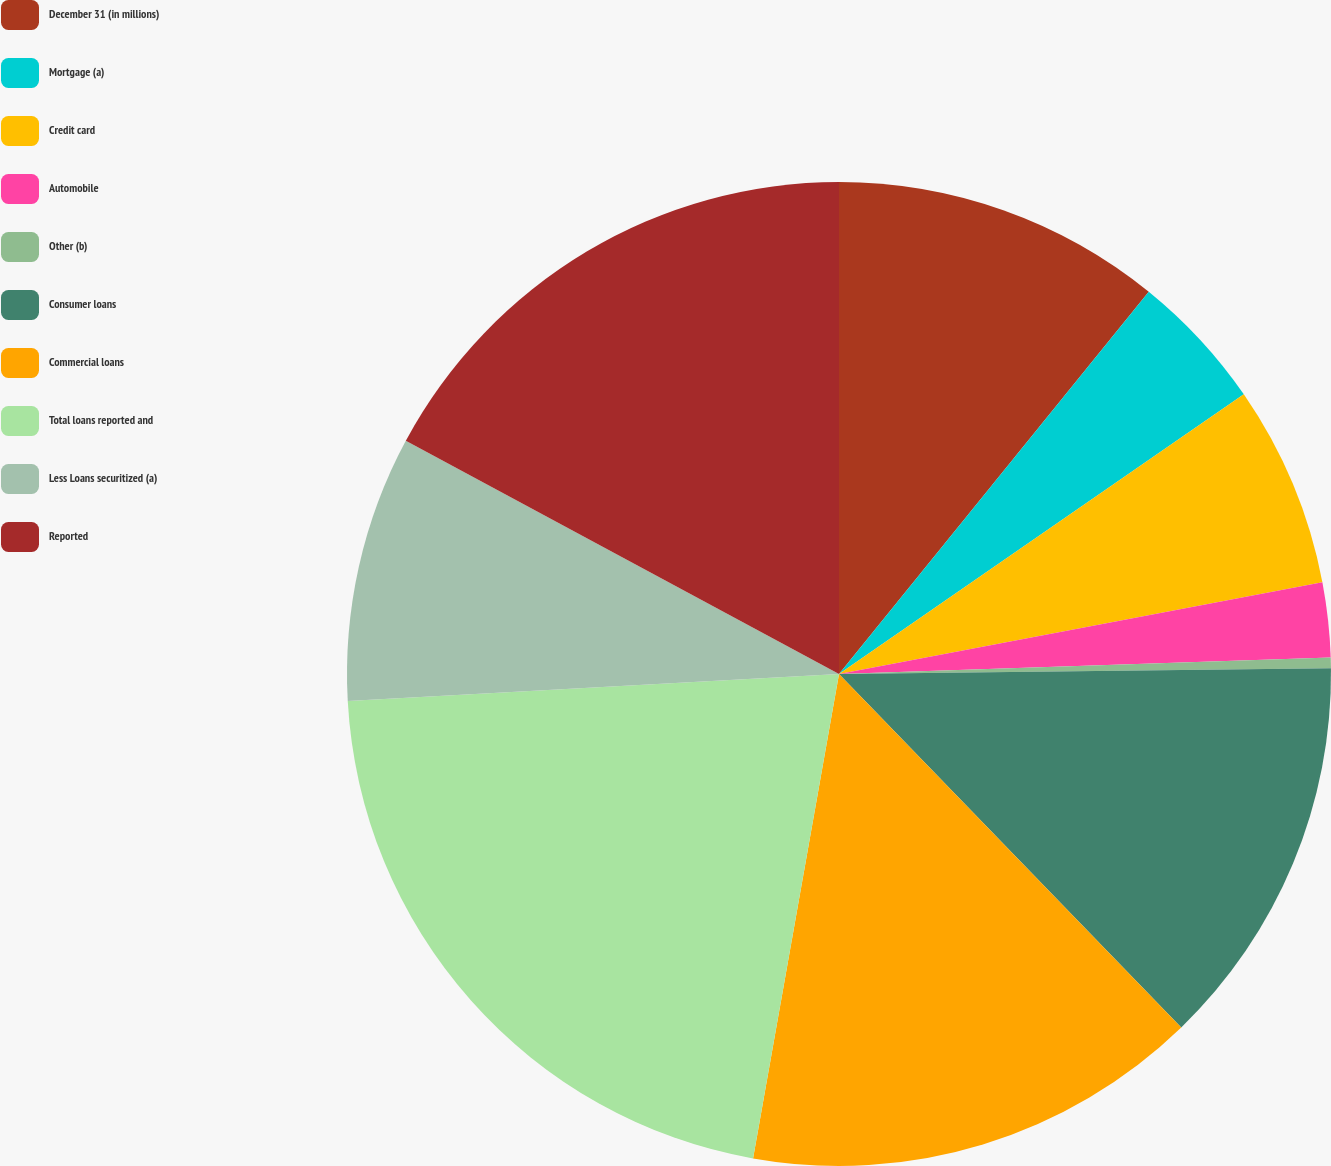<chart> <loc_0><loc_0><loc_500><loc_500><pie_chart><fcel>December 31 (in millions)<fcel>Mortgage (a)<fcel>Credit card<fcel>Automobile<fcel>Other (b)<fcel>Consumer loans<fcel>Commercial loans<fcel>Total loans reported and<fcel>Less Loans securitized (a)<fcel>Reported<nl><fcel>10.84%<fcel>4.54%<fcel>6.64%<fcel>2.45%<fcel>0.35%<fcel>12.94%<fcel>15.04%<fcel>21.33%<fcel>8.74%<fcel>17.14%<nl></chart> 